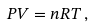<formula> <loc_0><loc_0><loc_500><loc_500>P V = n R T \, ,</formula> 